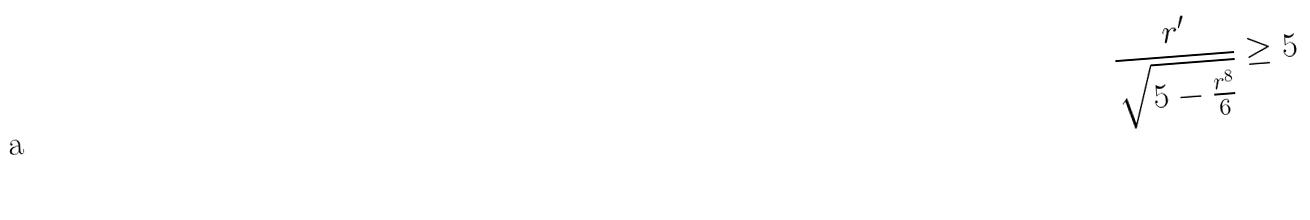<formula> <loc_0><loc_0><loc_500><loc_500>\frac { r ^ { \prime } } { \sqrt { 5 - \frac { r ^ { 8 } } { 6 } } } \geq 5</formula> 